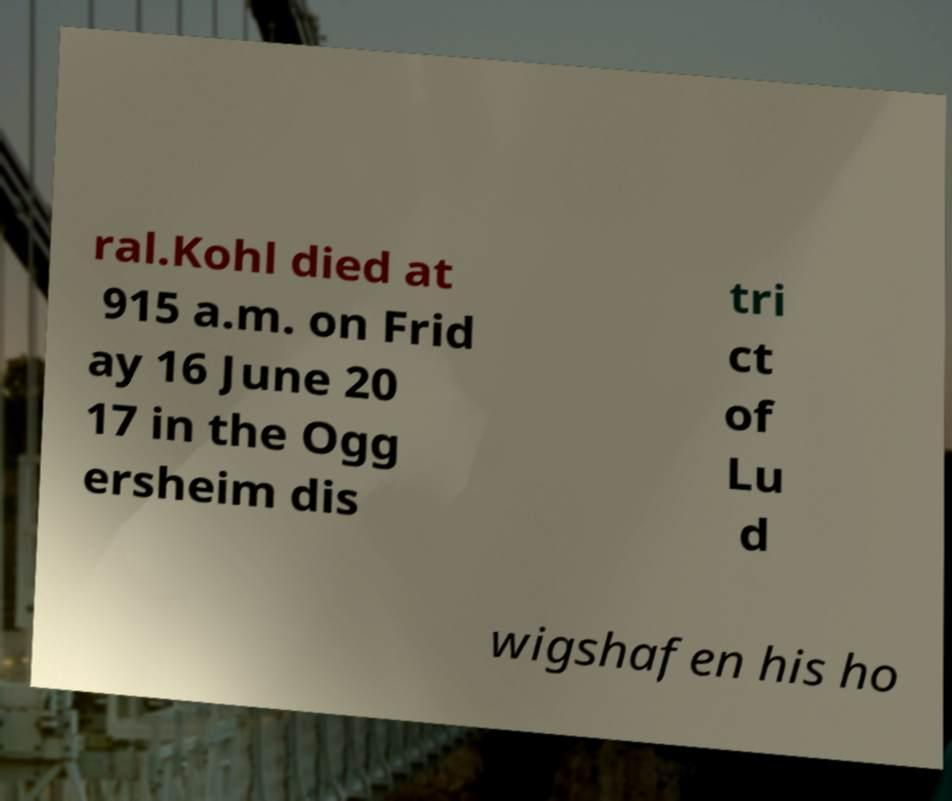Could you extract and type out the text from this image? ral.Kohl died at 915 a.m. on Frid ay 16 June 20 17 in the Ogg ersheim dis tri ct of Lu d wigshafen his ho 